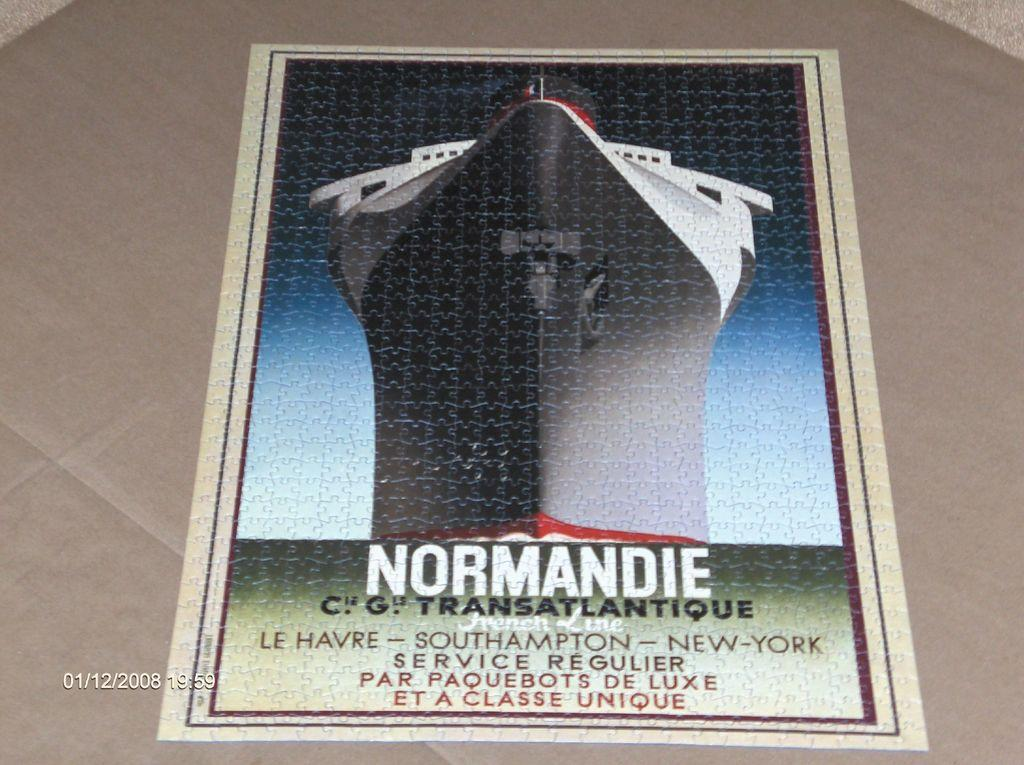<image>
Provide a brief description of the given image. A flyer for Normandie showcasing the very large boat. 